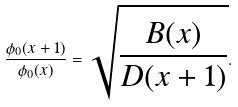<formula> <loc_0><loc_0><loc_500><loc_500>\frac { \phi _ { 0 } ( x + 1 ) } { \phi _ { 0 } ( x ) } = \sqrt { \frac { B ( x ) } { D ( x + 1 ) } } .</formula> 